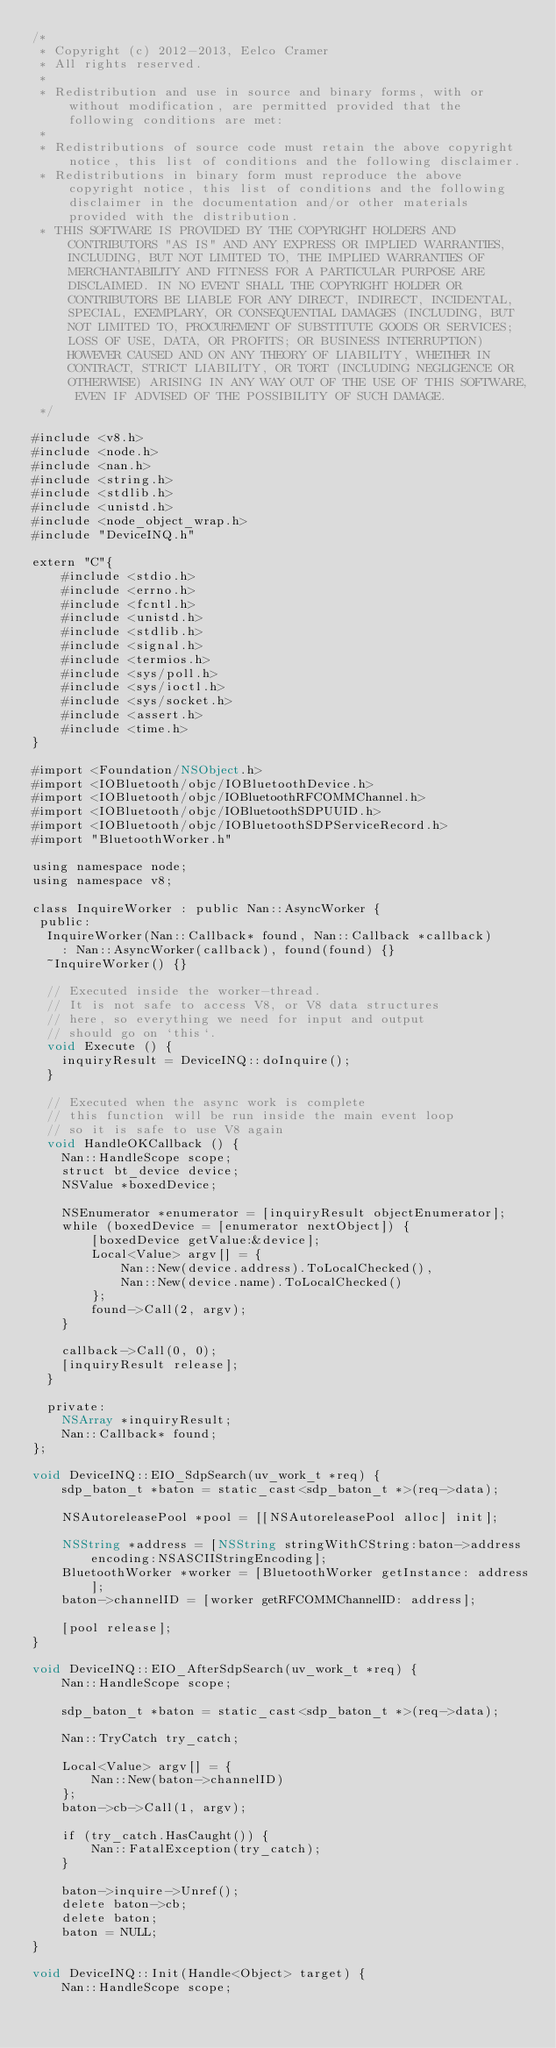Convert code to text. <code><loc_0><loc_0><loc_500><loc_500><_ObjectiveC_>/*
 * Copyright (c) 2012-2013, Eelco Cramer
 * All rights reserved.
 *
 * Redistribution and use in source and binary forms, with or without modification, are permitted provided that the following conditions are met:
 *
 * Redistributions of source code must retain the above copyright notice, this list of conditions and the following disclaimer.
 * Redistributions in binary form must reproduce the above copyright notice, this list of conditions and the following disclaimer in the documentation and/or other materials provided with the distribution.
 * THIS SOFTWARE IS PROVIDED BY THE COPYRIGHT HOLDERS AND CONTRIBUTORS "AS IS" AND ANY EXPRESS OR IMPLIED WARRANTIES, INCLUDING, BUT NOT LIMITED TO, THE IMPLIED WARRANTIES OF MERCHANTABILITY AND FITNESS FOR A PARTICULAR PURPOSE ARE DISCLAIMED. IN NO EVENT SHALL THE COPYRIGHT HOLDER OR CONTRIBUTORS BE LIABLE FOR ANY DIRECT, INDIRECT, INCIDENTAL, SPECIAL, EXEMPLARY, OR CONSEQUENTIAL DAMAGES (INCLUDING, BUT NOT LIMITED TO, PROCUREMENT OF SUBSTITUTE GOODS OR SERVICES; LOSS OF USE, DATA, OR PROFITS; OR BUSINESS INTERRUPTION) HOWEVER CAUSED AND ON ANY THEORY OF LIABILITY, WHETHER IN CONTRACT, STRICT LIABILITY, OR TORT (INCLUDING NEGLIGENCE OR OTHERWISE) ARISING IN ANY WAY OUT OF THE USE OF THIS SOFTWARE, EVEN IF ADVISED OF THE POSSIBILITY OF SUCH DAMAGE.
 */

#include <v8.h>
#include <node.h>
#include <nan.h>
#include <string.h>
#include <stdlib.h>
#include <unistd.h>
#include <node_object_wrap.h>
#include "DeviceINQ.h"

extern "C"{
    #include <stdio.h>
    #include <errno.h>
    #include <fcntl.h>
    #include <unistd.h>
    #include <stdlib.h>
    #include <signal.h>
    #include <termios.h>
    #include <sys/poll.h>
    #include <sys/ioctl.h>
    #include <sys/socket.h>
    #include <assert.h>
    #include <time.h>
}

#import <Foundation/NSObject.h>
#import <IOBluetooth/objc/IOBluetoothDevice.h>
#import <IOBluetooth/objc/IOBluetoothRFCOMMChannel.h>
#import <IOBluetooth/objc/IOBluetoothSDPUUID.h>
#import <IOBluetooth/objc/IOBluetoothSDPServiceRecord.h>
#import "BluetoothWorker.h"

using namespace node;
using namespace v8;

class InquireWorker : public Nan::AsyncWorker {
 public:
  InquireWorker(Nan::Callback* found, Nan::Callback *callback)
    : Nan::AsyncWorker(callback), found(found) {}
  ~InquireWorker() {}

  // Executed inside the worker-thread.
  // It is not safe to access V8, or V8 data structures
  // here, so everything we need for input and output
  // should go on `this`.
  void Execute () {
    inquiryResult = DeviceINQ::doInquire();
  }

  // Executed when the async work is complete
  // this function will be run inside the main event loop
  // so it is safe to use V8 again
  void HandleOKCallback () {
    Nan::HandleScope scope;
    struct bt_device device;
    NSValue *boxedDevice;

    NSEnumerator *enumerator = [inquiryResult objectEnumerator];
    while (boxedDevice = [enumerator nextObject]) {
        [boxedDevice getValue:&device];
        Local<Value> argv[] = {
            Nan::New(device.address).ToLocalChecked(),
            Nan::New(device.name).ToLocalChecked()
        };
        found->Call(2, argv);
    }

    callback->Call(0, 0);
    [inquiryResult release];
  }

  private:
    NSArray *inquiryResult;
    Nan::Callback* found;
};

void DeviceINQ::EIO_SdpSearch(uv_work_t *req) {
    sdp_baton_t *baton = static_cast<sdp_baton_t *>(req->data);

    NSAutoreleasePool *pool = [[NSAutoreleasePool alloc] init];

    NSString *address = [NSString stringWithCString:baton->address encoding:NSASCIIStringEncoding];
    BluetoothWorker *worker = [BluetoothWorker getInstance: address];
    baton->channelID = [worker getRFCOMMChannelID: address];

    [pool release];
}

void DeviceINQ::EIO_AfterSdpSearch(uv_work_t *req) {
    Nan::HandleScope scope;

    sdp_baton_t *baton = static_cast<sdp_baton_t *>(req->data);

    Nan::TryCatch try_catch;

    Local<Value> argv[] = {
        Nan::New(baton->channelID)
    };
    baton->cb->Call(1, argv);

    if (try_catch.HasCaught()) {
        Nan::FatalException(try_catch);
    }

    baton->inquire->Unref();
    delete baton->cb;
    delete baton;
    baton = NULL;
}

void DeviceINQ::Init(Handle<Object> target) {
    Nan::HandleScope scope;
</code> 